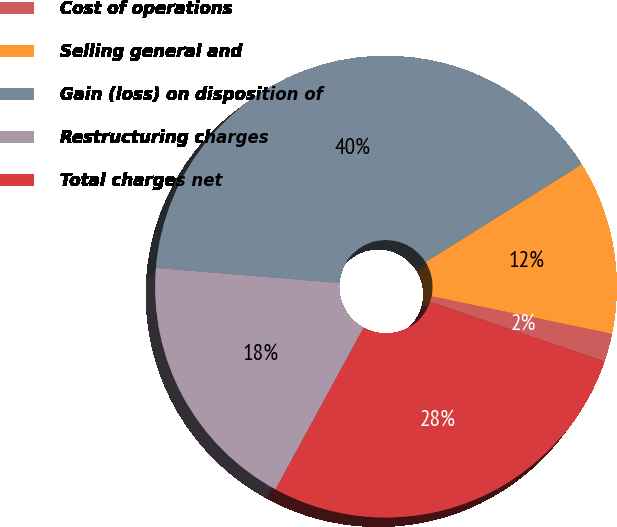<chart> <loc_0><loc_0><loc_500><loc_500><pie_chart><fcel>Cost of operations<fcel>Selling general and<fcel>Gain (loss) on disposition of<fcel>Restructuring charges<fcel>Total charges net<nl><fcel>1.98%<fcel>12.15%<fcel>39.81%<fcel>18.37%<fcel>27.7%<nl></chart> 